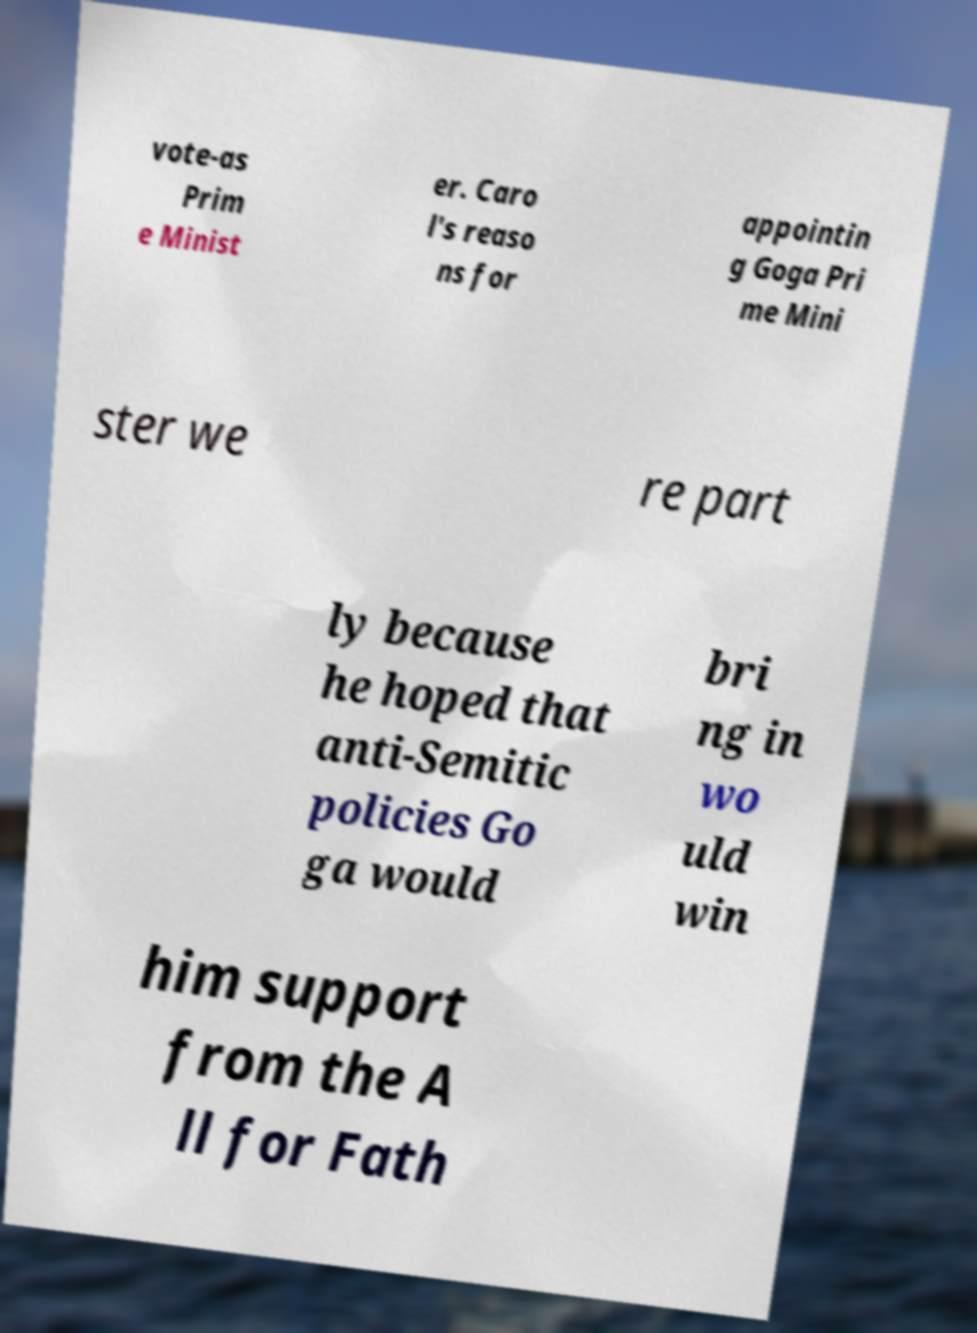For documentation purposes, I need the text within this image transcribed. Could you provide that? vote-as Prim e Minist er. Caro l's reaso ns for appointin g Goga Pri me Mini ster we re part ly because he hoped that anti-Semitic policies Go ga would bri ng in wo uld win him support from the A ll for Fath 